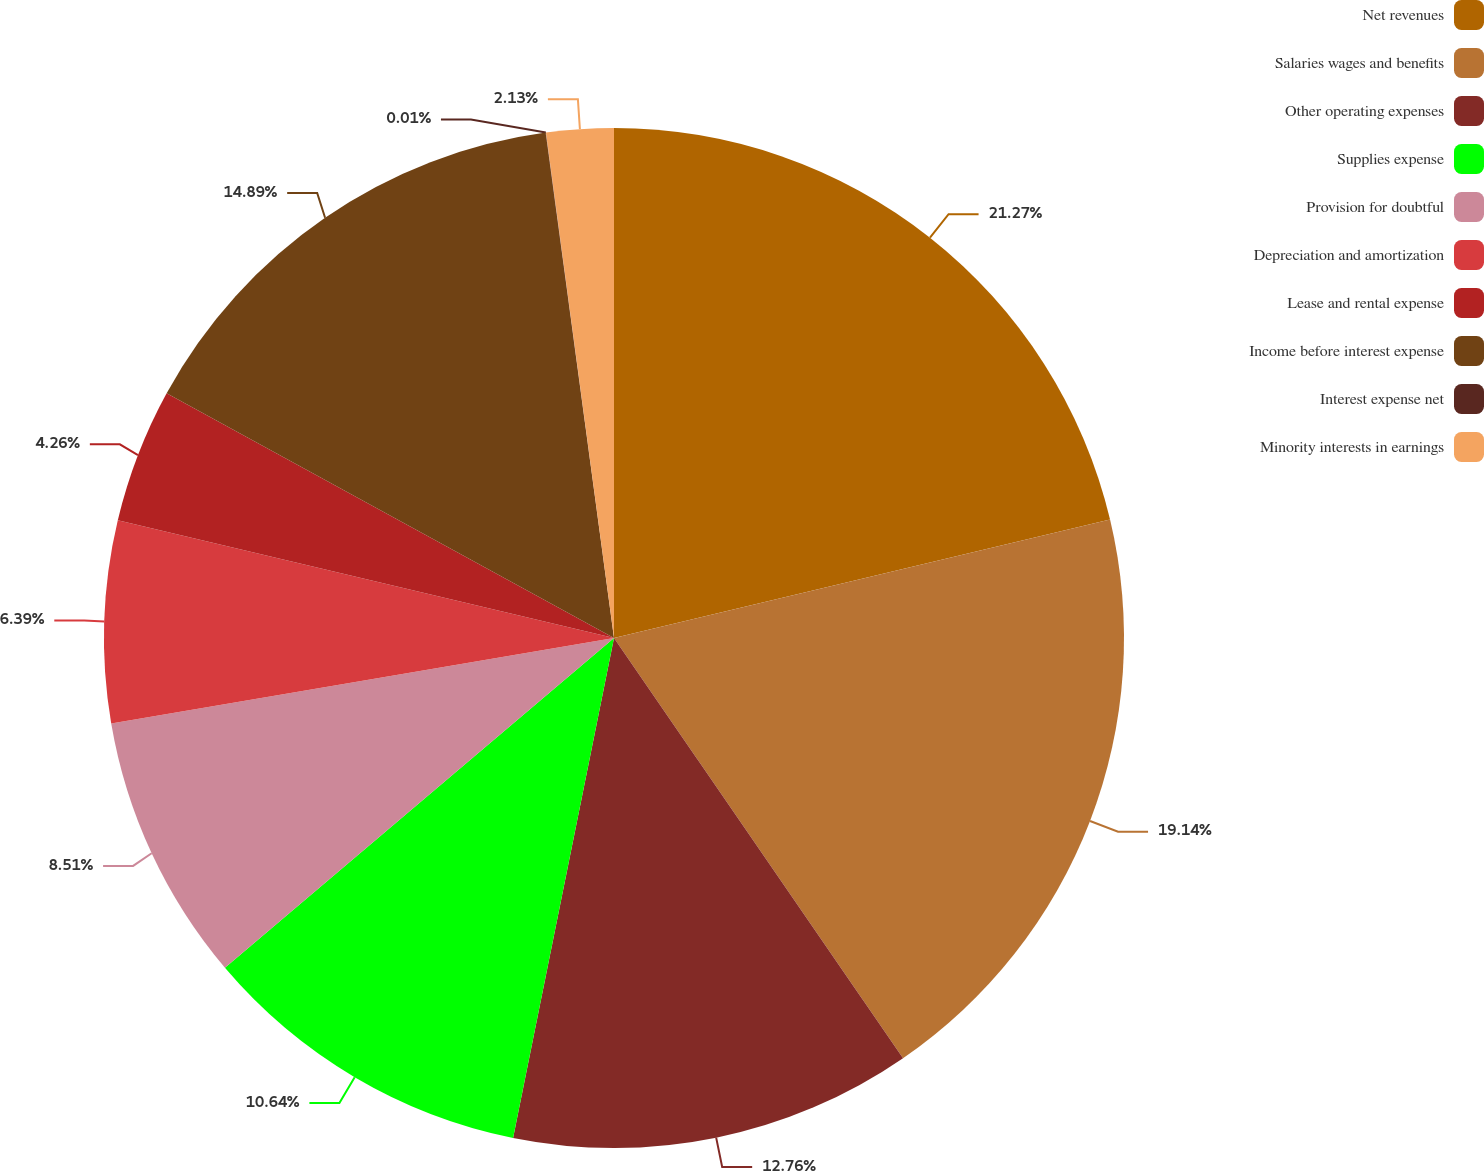Convert chart. <chart><loc_0><loc_0><loc_500><loc_500><pie_chart><fcel>Net revenues<fcel>Salaries wages and benefits<fcel>Other operating expenses<fcel>Supplies expense<fcel>Provision for doubtful<fcel>Depreciation and amortization<fcel>Lease and rental expense<fcel>Income before interest expense<fcel>Interest expense net<fcel>Minority interests in earnings<nl><fcel>21.27%<fcel>19.14%<fcel>12.76%<fcel>10.64%<fcel>8.51%<fcel>6.39%<fcel>4.26%<fcel>14.89%<fcel>0.01%<fcel>2.13%<nl></chart> 